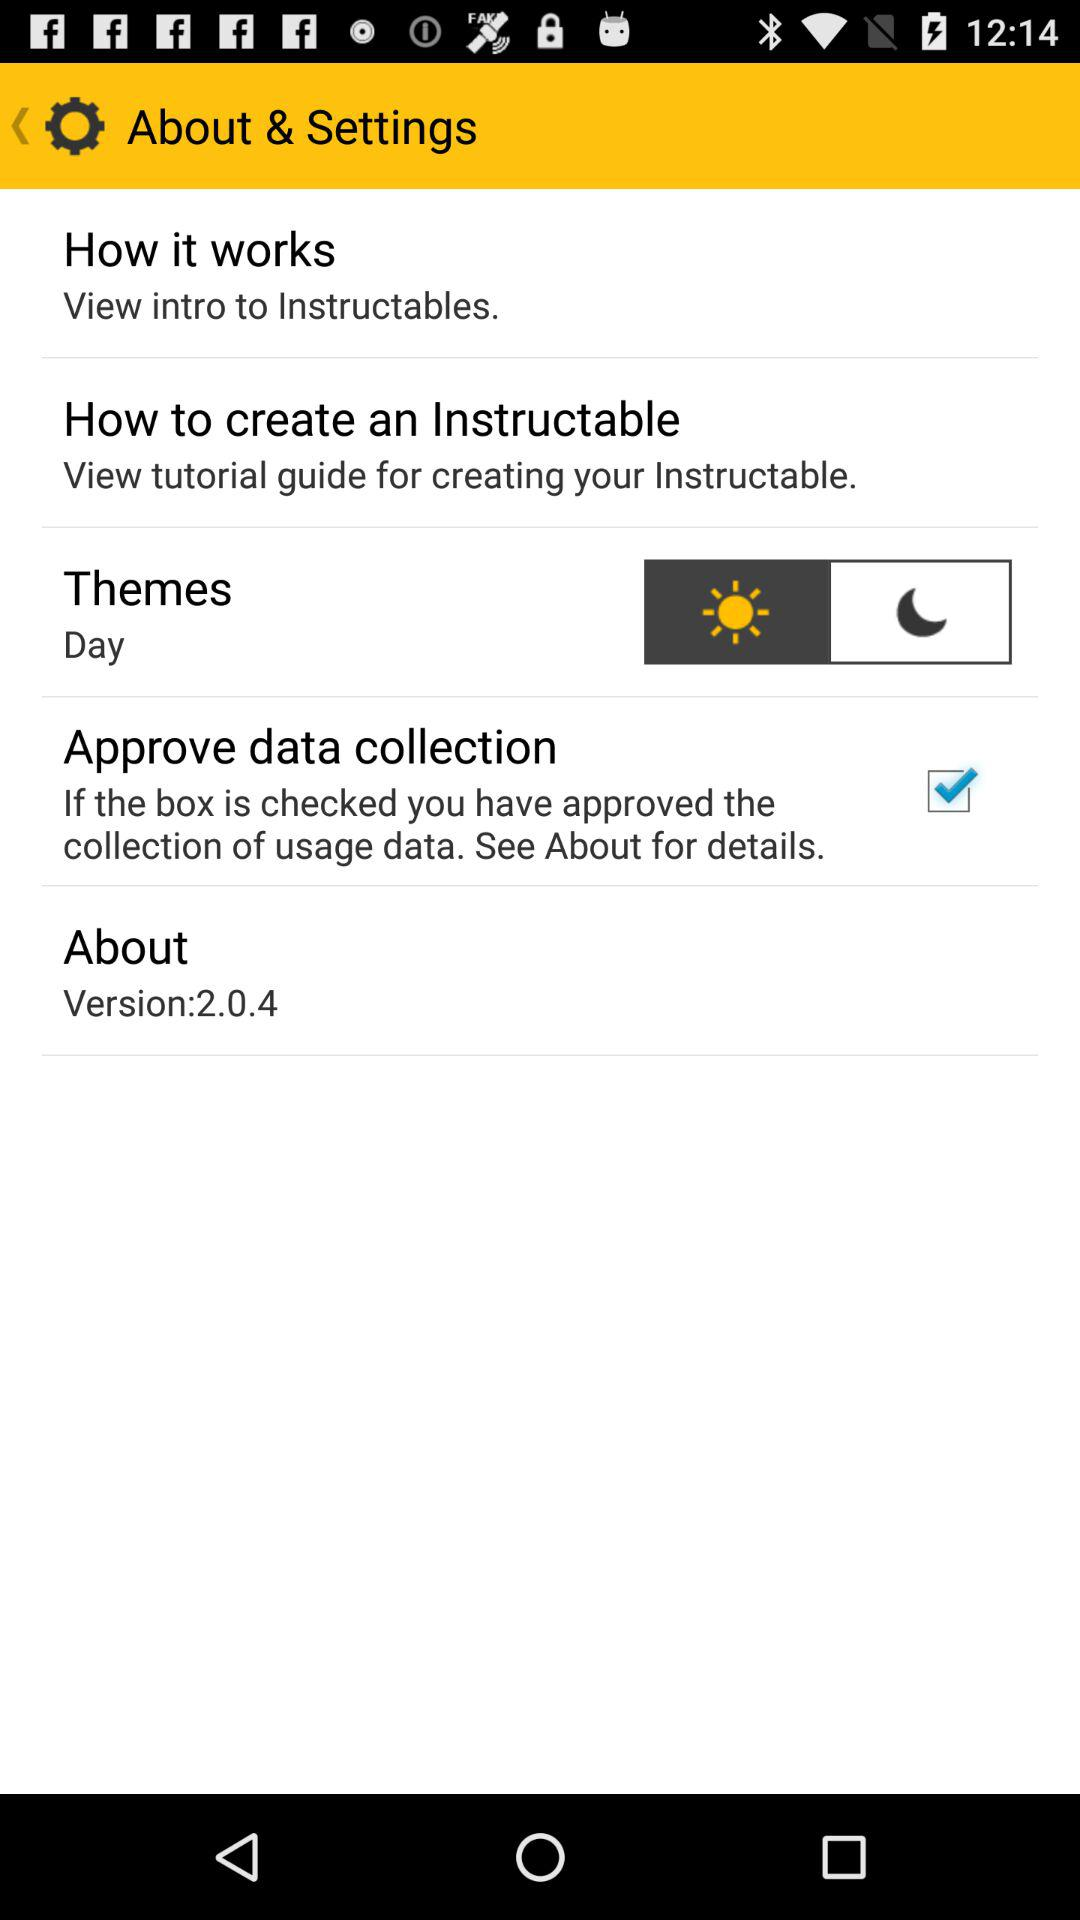What is the status of "Approve data collection"? The status is "on". 